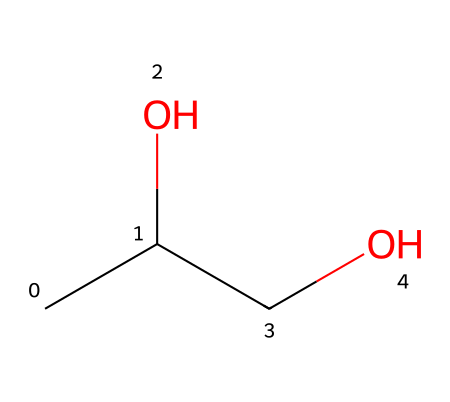What is the main functional group in propylene glycol? The structure shows an -OH group, which indicates the presence of an alcohol functional group. The carbon atoms are connected to hydroxyl groups, characteristic of alcohols.
Answer: alcohol How many carbon atoms are present in propylene glycol? By examining the SMILES, there are three "C" symbols, indicating three carbon atoms in the structure of propylene glycol.
Answer: three What property does propylene glycol impart to moist dog food? Propylene glycol acts as a humectant, which helps to retain moisture in pet food and prevent it from drying out.
Answer: humectant What is the total number of hydrogen atoms in propylene glycol? Counting the hydrogens in the structure: each carbon typically forms four bonds, and based on the connectivity in the SMILES, there are eight hydrogen atoms total in the structure.
Answer: eight Is propylene glycol safe for dogs in food? YES, propylene glycol is generally recognized as safe (GRAS) for use in pet food, according to regulatory authorities.
Answer: YES How is propylene glycol classified in terms of its chemical nature? Considering its structure and applications, propylene glycol is classified as a diol or glycol, which are types of alcohols containing two hydroxyl groups.
Answer: diol 